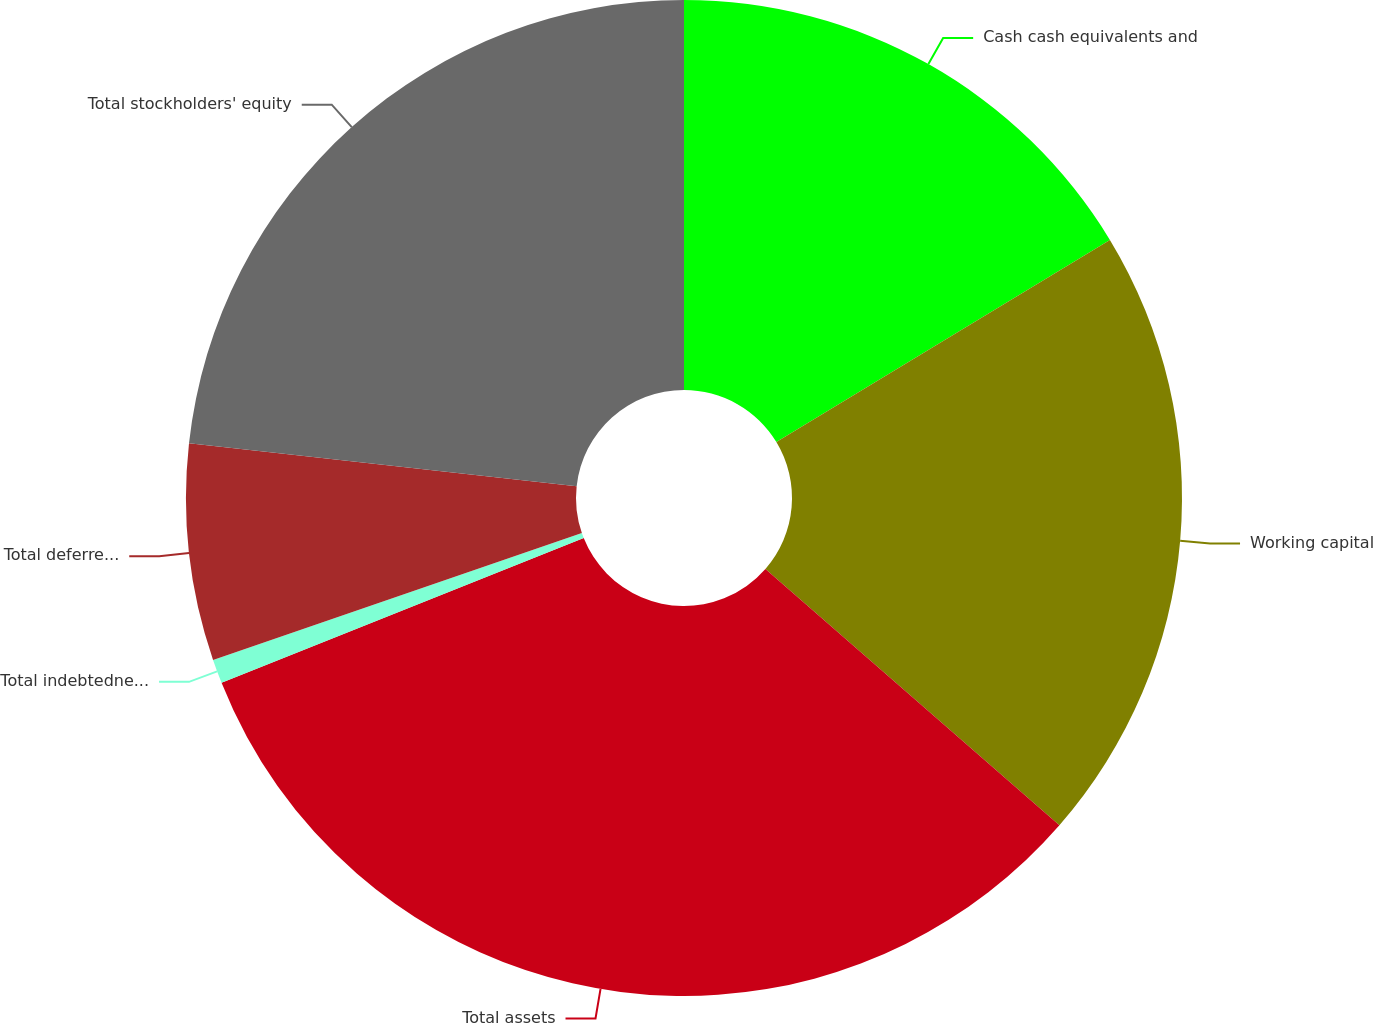<chart> <loc_0><loc_0><loc_500><loc_500><pie_chart><fcel>Cash cash equivalents and<fcel>Working capital<fcel>Total assets<fcel>Total indebtedness (1)<fcel>Total deferred revenue<fcel>Total stockholders' equity<nl><fcel>16.33%<fcel>20.08%<fcel>32.54%<fcel>0.78%<fcel>7.02%<fcel>23.25%<nl></chart> 